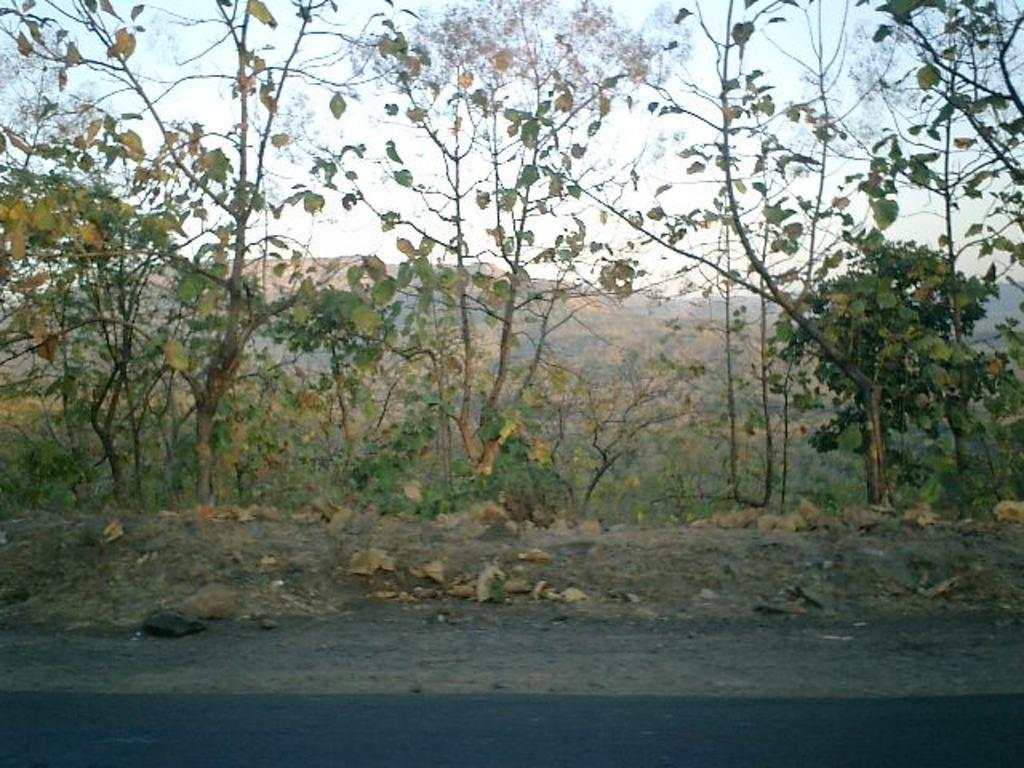What type of landscape is depicted in the image? The image features hills and trees, indicating a natural landscape. What other types of vegetation can be seen in the image? In addition to trees, there are plants visible in the image. What is visible in the background of the image? The sky is visible in the image. What is located at the bottom of the image? There is a road at the bottom of the image. What type of juice is being served in the image? There is no juice present in the image; it features a natural landscape with hills, trees, plants, sky, and a road. What is the string used for in the image? There is no string present in the image. 